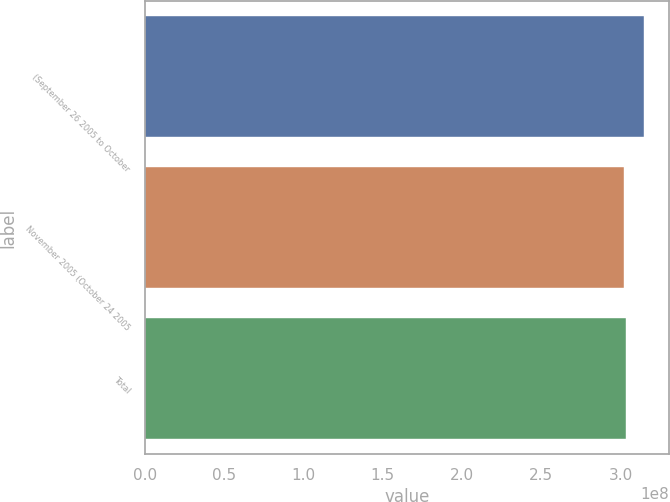Convert chart to OTSL. <chart><loc_0><loc_0><loc_500><loc_500><bar_chart><fcel>(September 26 2005 to October<fcel>November 2005 (October 24 2005<fcel>Total<nl><fcel>3.14702e+08<fcel>3.0197e+08<fcel>3.03243e+08<nl></chart> 